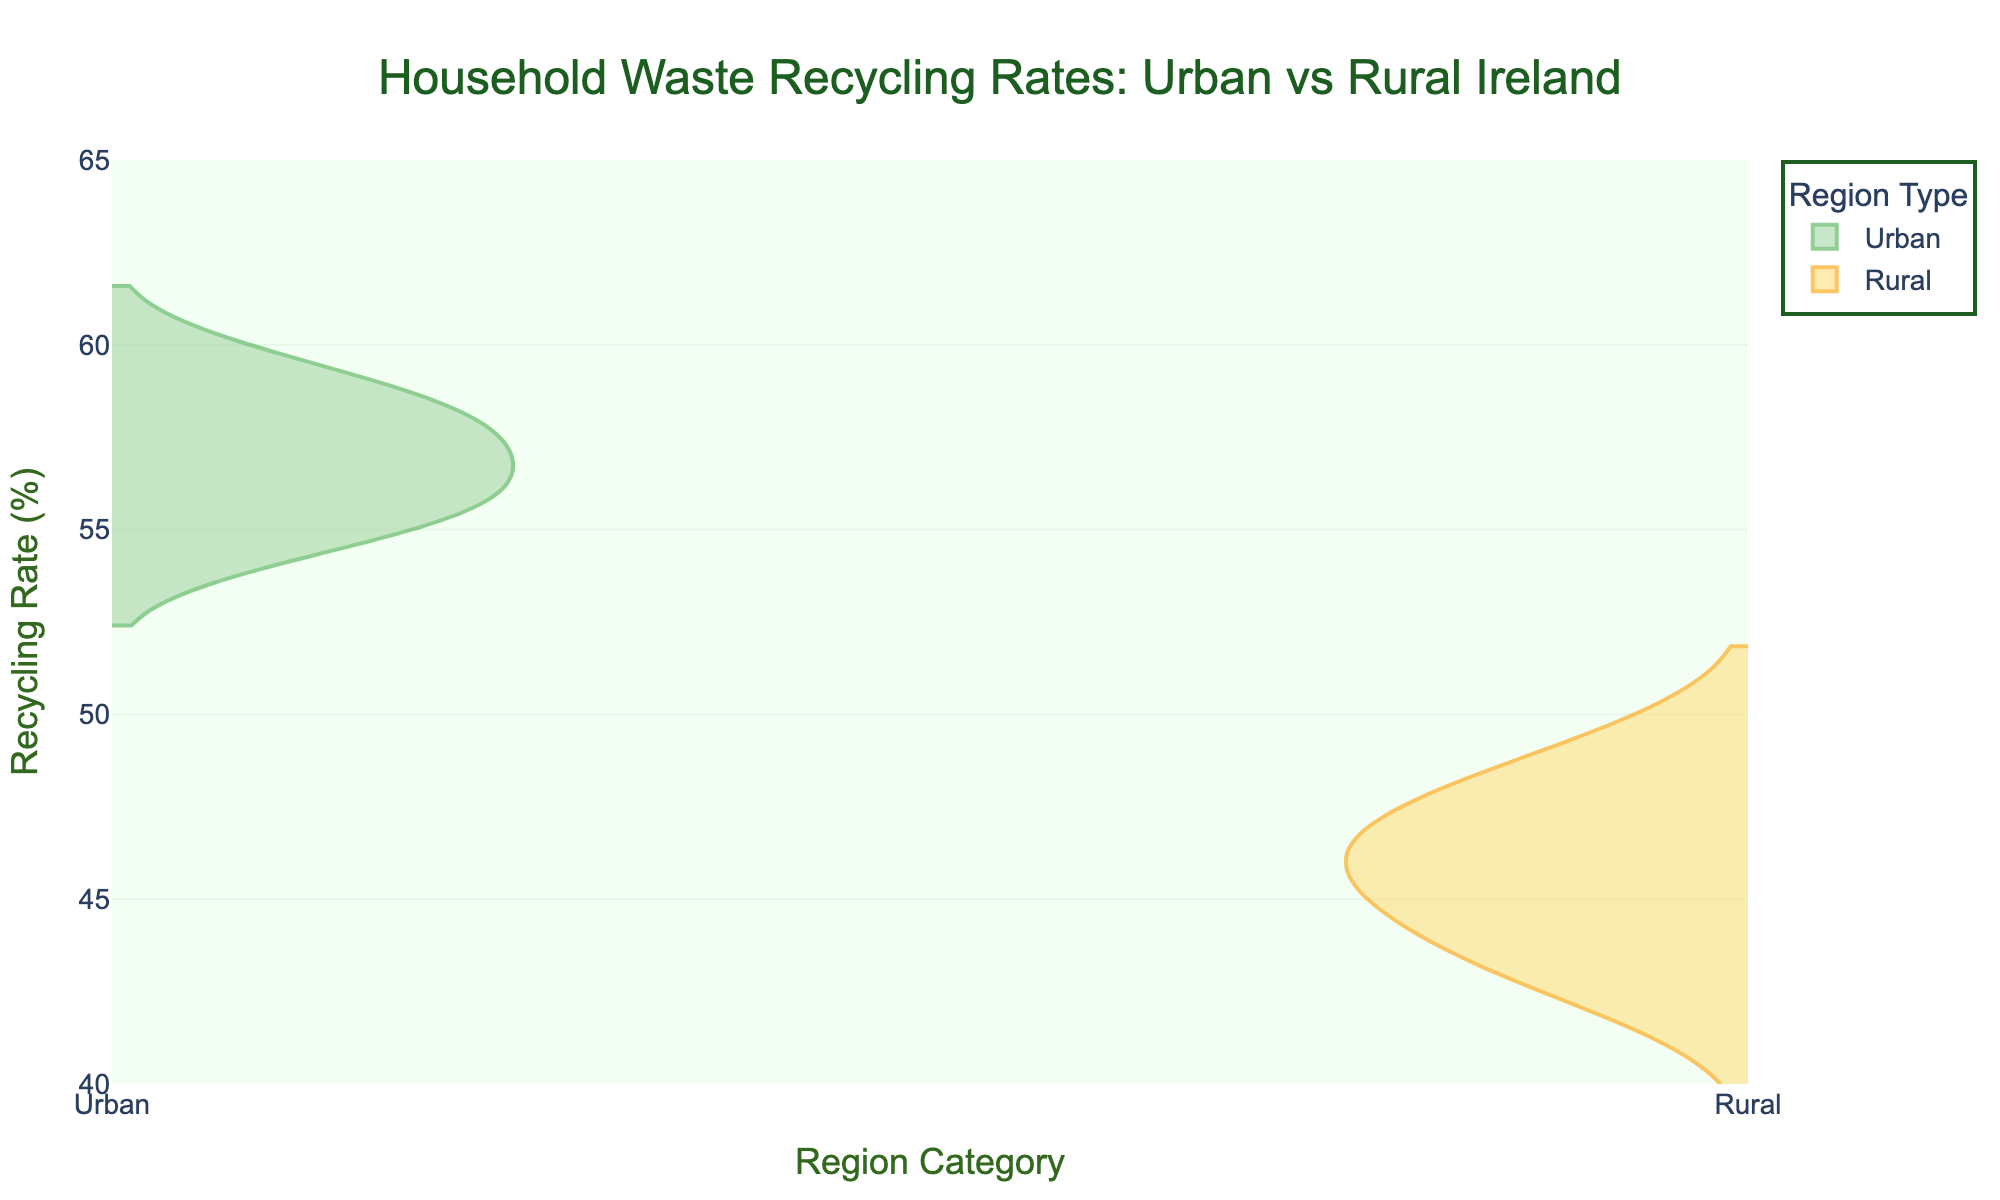What is the title of the figure? The title is displayed at the top center of the figure, and it reads "Household Waste Recycling Rates: Urban vs Rural Ireland".
Answer: Household Waste Recycling Rates: Urban vs Rural Ireland What is the y-axis label? The y-axis label is provided in the figure and states the metric being measured, which is "Recycling Rate (%)".
Answer: Recycling Rate (%) Which region type has the highest maximum recycling rate? Observing the provided violin plot, the green-colored (Urban) side has the highest maximum recycling rate, reaching up to around 60%.
Answer: Urban What is the range of recycling rates for rural areas? By looking at the orange-colored (Rural) side of the violin plot, the recycling rates range from approximately 42.8% to 48.7%.
Answer: Approximately 42.8% to 48.7% How does the median recycling rate of urban areas compare to the median of rural areas? In the violin plot, the median is represented by the white dot. The white dot in the green-colored (Urban) side is higher than the white dot in the orange-colored (Rural) side, indicating a higher median recycling rate for urban areas.
Answer: Urban median is higher What is the visual difference in the spread of recycling rates between urban and rural areas? The spread or distribution of recycling rates is wider in urban areas (spread from around 54.8% to 59.2%) compared to rural areas, which have a tighter range (spread from around 42.8% to 48.7%).
Answer: Urban has a wider spread Is there more variation in recycling rates within urban or rural areas? Variation can be assessed by the width and spread of the violin plots. The urban area has a wider spread, indicating more variation in recycling rates.
Answer: Urban Between urban and rural areas, which has the lowest recycling rate? By reviewing the lower tails of both violin plots, the rural areas have the lowest recycling rate at around 42.8%.
Answer: Rural Which region type shows more consistency in recycling rates? Consistency in recycling rates can be inferred from the width of the violin plots. The rural areas show a tighter, narrower spread, indicating more consistency.
Answer: Rural 